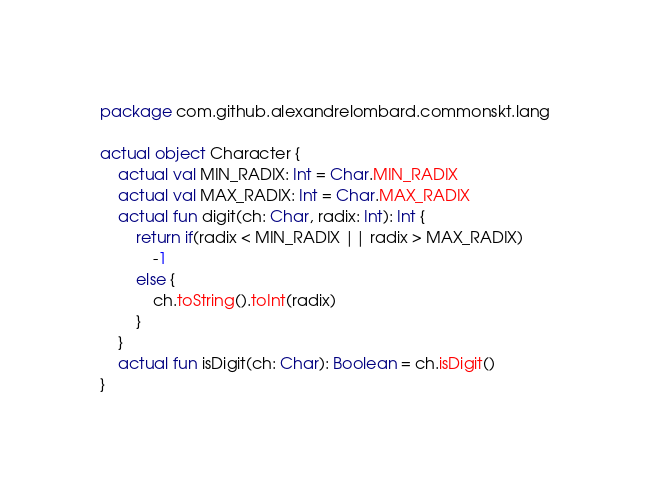Convert code to text. <code><loc_0><loc_0><loc_500><loc_500><_Kotlin_>package com.github.alexandrelombard.commonskt.lang

actual object Character {
    actual val MIN_RADIX: Int = Char.MIN_RADIX
    actual val MAX_RADIX: Int = Char.MAX_RADIX
    actual fun digit(ch: Char, radix: Int): Int {
        return if(radix < MIN_RADIX || radix > MAX_RADIX)
            -1
        else {
            ch.toString().toInt(radix)
        }
    }
    actual fun isDigit(ch: Char): Boolean = ch.isDigit()
}</code> 